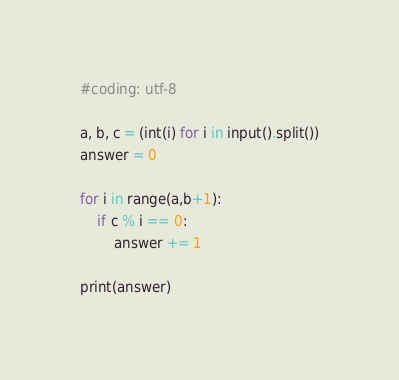Convert code to text. <code><loc_0><loc_0><loc_500><loc_500><_Python_>#coding: utf-8

a, b, c = (int(i) for i in input().split())
answer = 0

for i in range(a,b+1):
    if c % i == 0:
        answer += 1

print(answer)
</code> 